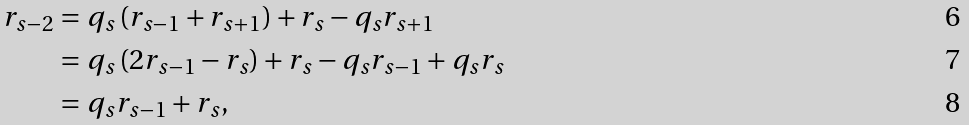<formula> <loc_0><loc_0><loc_500><loc_500>r _ { s - 2 } & = q _ { s } \left ( r _ { s - 1 } + r _ { s + 1 } \right ) + r _ { s } - q _ { s } r _ { s + 1 } \\ & = q _ { s } \left ( 2 r _ { s - 1 } - r _ { s } \right ) + r _ { s } - q _ { s } r _ { s - 1 } + q _ { s } r _ { s } \\ & = q _ { s } r _ { s - 1 } + r _ { s } ,</formula> 